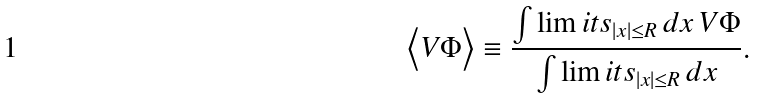<formula> <loc_0><loc_0><loc_500><loc_500>\Big < V \Phi \Big > \equiv \frac { \int \lim i t s _ { | x | \leq R } \, d x \, V \Phi } { \int \lim i t s _ { | x | \leq R } \, d x } .</formula> 